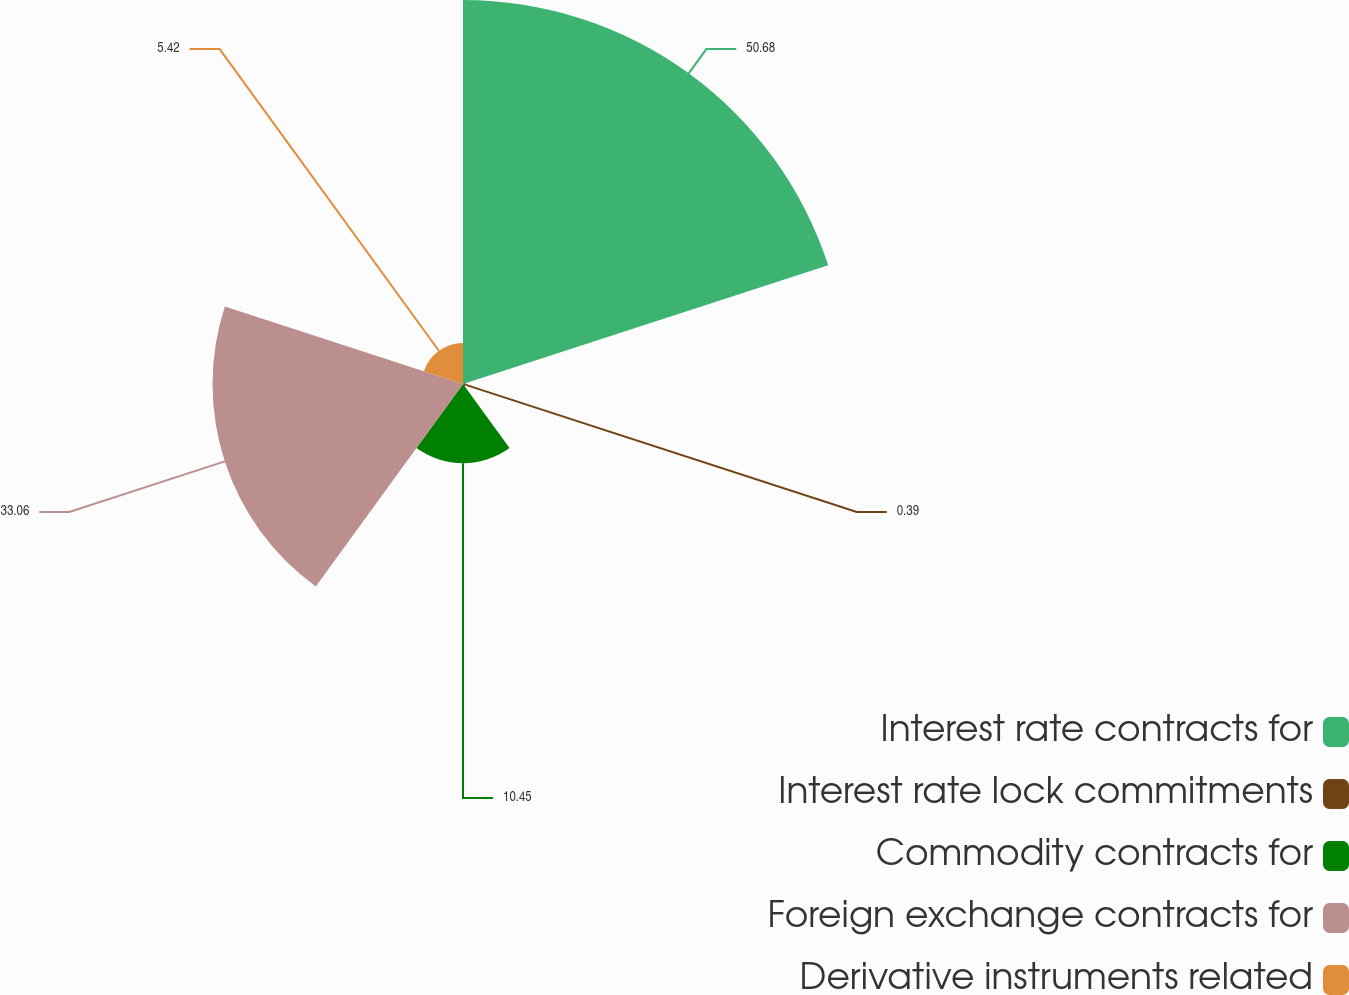Convert chart. <chart><loc_0><loc_0><loc_500><loc_500><pie_chart><fcel>Interest rate contracts for<fcel>Interest rate lock commitments<fcel>Commodity contracts for<fcel>Foreign exchange contracts for<fcel>Derivative instruments related<nl><fcel>50.69%<fcel>0.39%<fcel>10.45%<fcel>33.06%<fcel>5.42%<nl></chart> 